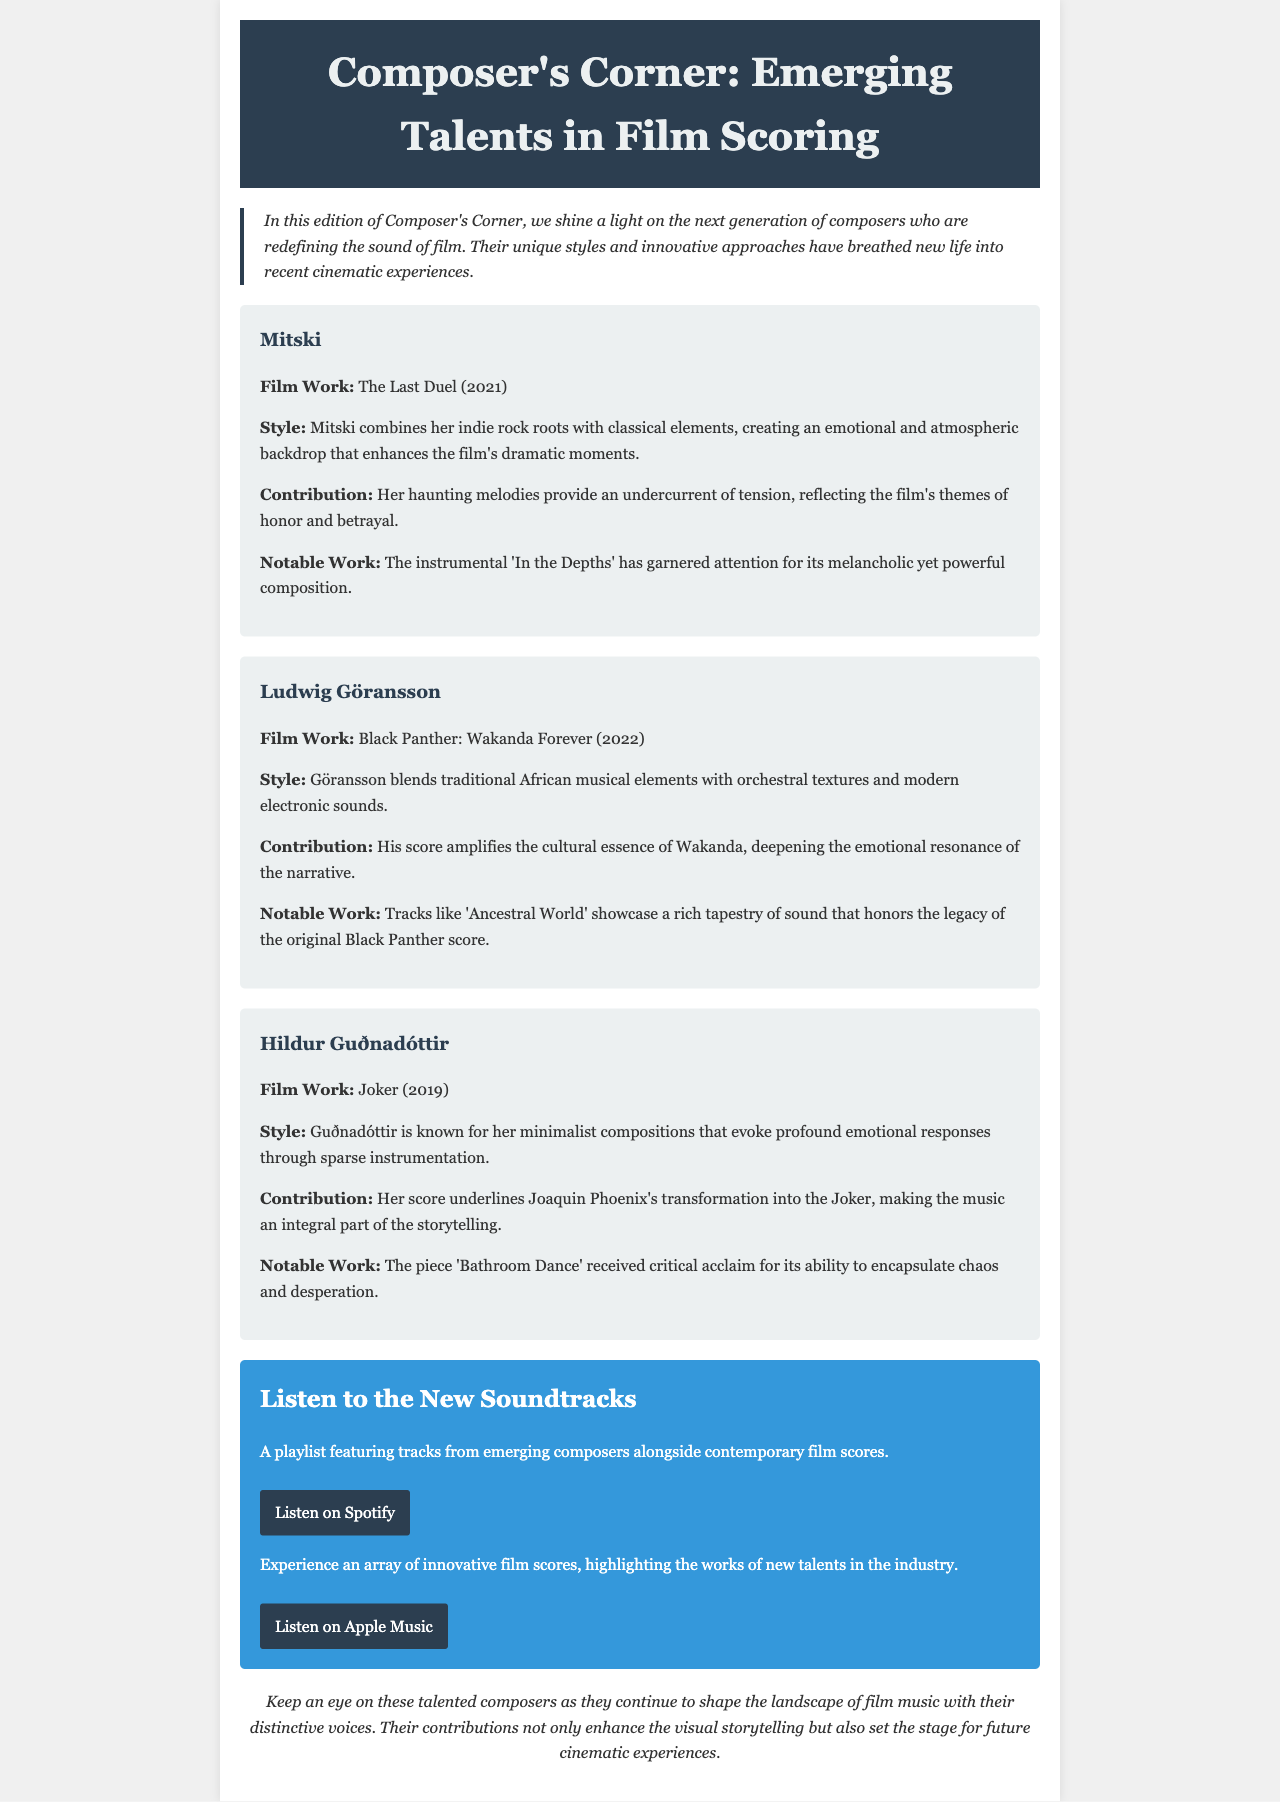What is the title of the newsletter? The title is prominently displayed in the header section of the newsletter.
Answer: Composer's Corner: Emerging Talents in Film Scoring Who is the composer featured for the film "The Last Duel"? The newsletter mentions specific composers alongside their notable film works.
Answer: Mitski What year was "Black Panther: Wakanda Forever" released? The release year is provided in each composer's section next to their film work.
Answer: 2022 What unique style does Hildur Guðnadóttir use in her compositions? Each featured composer has a section detailing their individual style.
Answer: Minimalist compositions Which track by Mitski is noted for its melancholic composition? The notable work for each composer is listed in their respective section.
Answer: In the Depths How does Ludwig Göransson’s score contribute to "Black Panther: Wakanda Forever"? This question requires reasoning over both contributions and specific film context mentioned.
Answer: Amplifies the cultural essence of Wakanda What type of playlists are included in the newsletter? The newsletter describes a section that features playlists for listening to music.
Answer: Curated playlists What emotional aspect does Hildur Guðnadóttir's score capture in "Joker"? This question combines knowledge of her work with its emotional impact in the film.
Answer: Chaos and desperation 